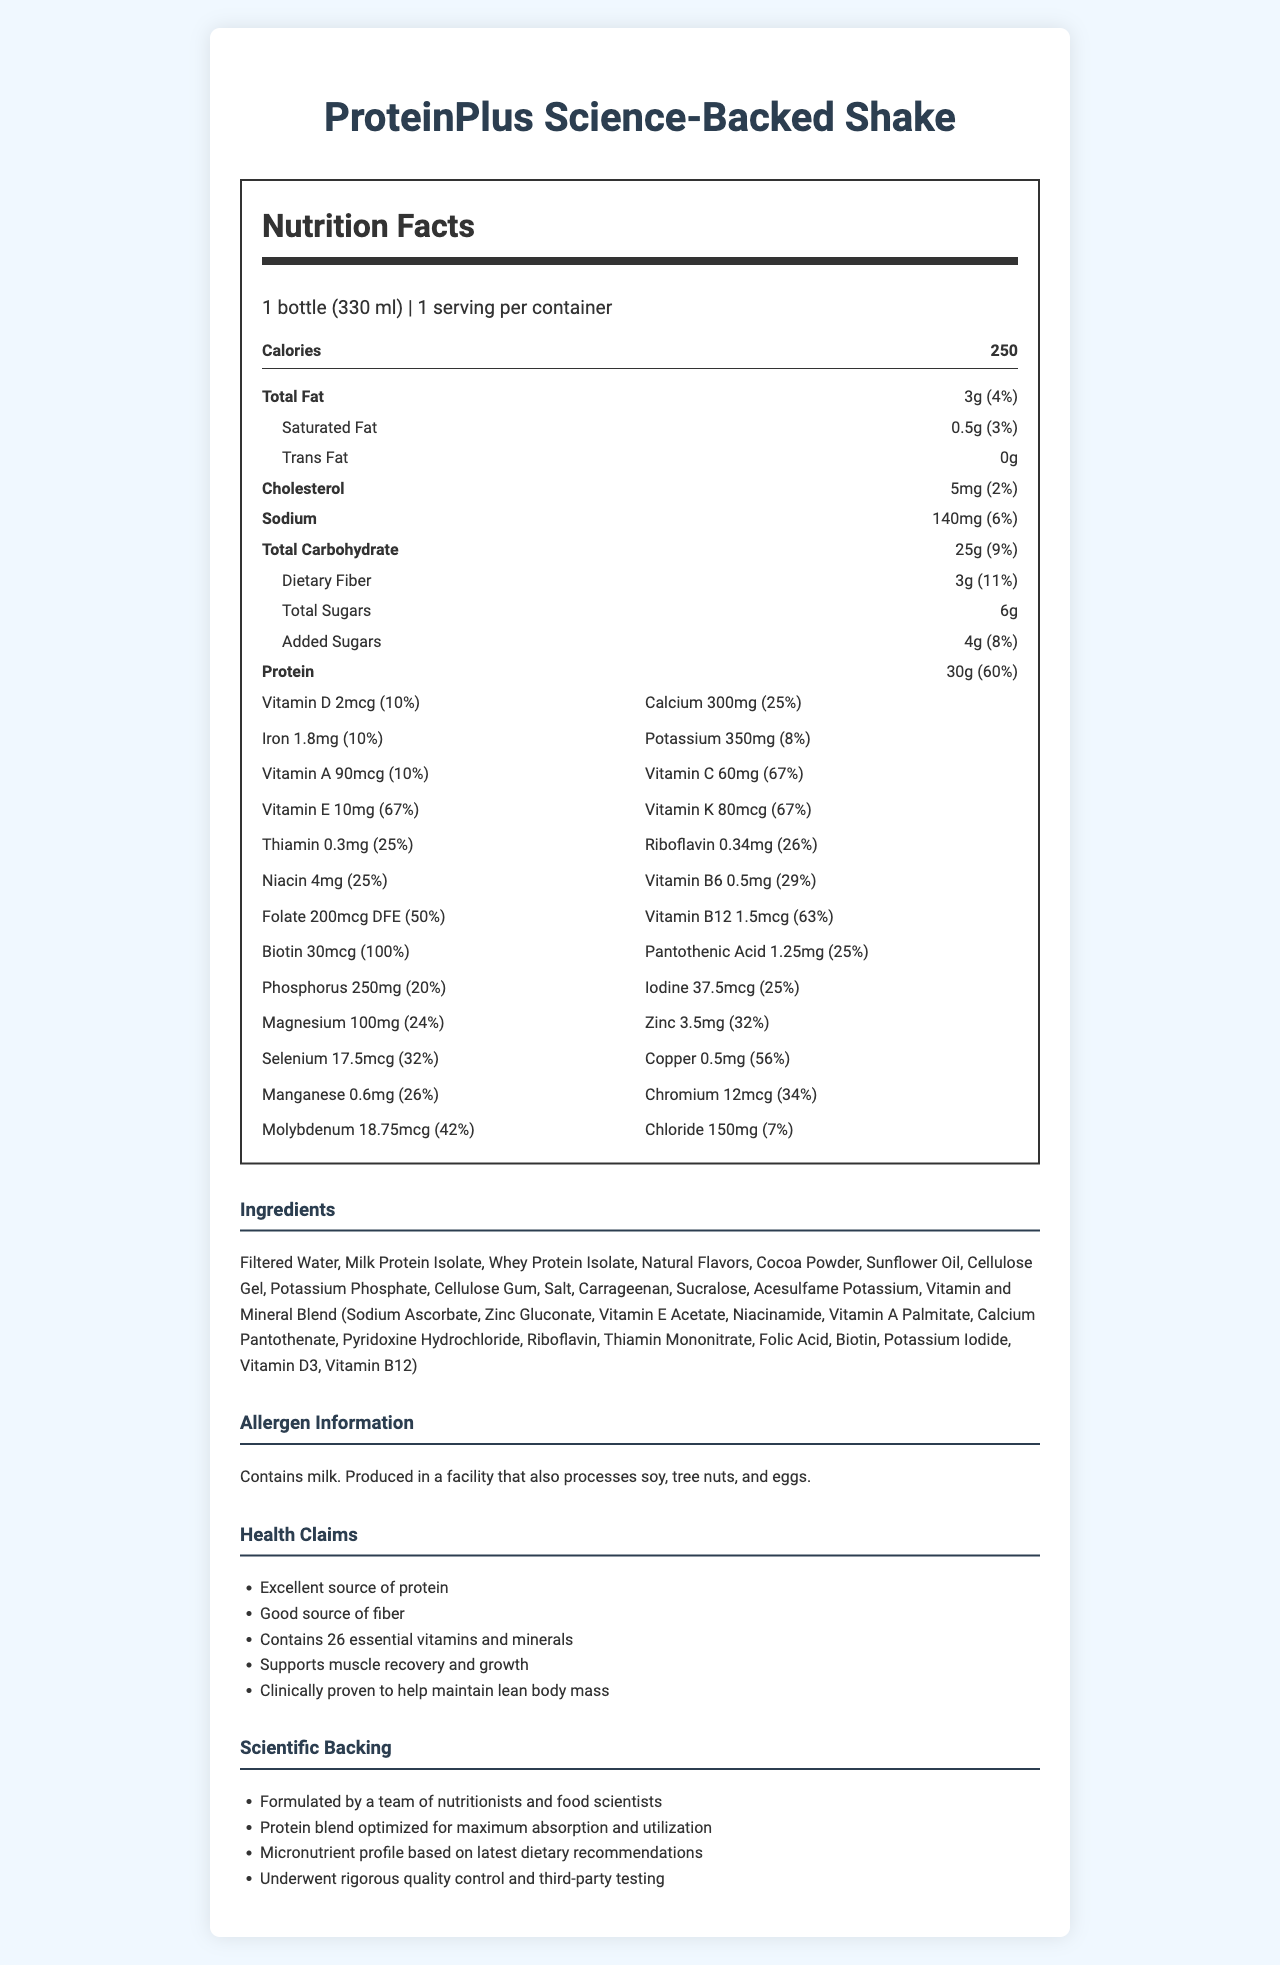what is the serving size of the ProteinPlus Science-Backed Shake? The serving size is listed in the serving information section as "1 bottle (330 ml)".
Answer: 1 bottle (330 ml) how many calories does the shake have per serving? The document states that there are 250 calories per serving, located right under the Nutrition Facts heading.
Answer: 250 calories how much protein does the shake contain? The document lists protein content as 30g under the nutrient breakdown.
Answer: 30g what percentage of the daily value of calcium does the shake provide? The document specifies that the shake contains 300mg of calcium which constitutes 25% of the daily value.
Answer: 25% what is the amount of vitamin B12 in the shake? The vitamin content section lists 1.5mcg of vitamin B12, providing 63% of the daily value.
Answer: 1.5mcg which of the following vitamins has the highest daily value percentage? A. Vitamin A B. Vitamin C C. Vitamin E D. Vitamin B12 The document shows Vitamin E, Vitamin C, and Vitamin K each at 67% of the daily value, tied for the highest percentage.
Answer: C which ingredient is not present in the shake's list? A. Sucralose B. Almond Milk C. Cellulose Gel D. Whey Protein Isolate Almond Milk is not listed in the ingredient section, while the other options are.
Answer: B does the protein shake contain milk? The allergen information section states that the shake contains milk.
Answer: Yes describe the main idea of the document The document presents an in-depth look at the shake's nutritional profile, focusing on what micronutrients are included, their daily value percentages, and additional health benefits backed by scientific research.
Answer: The document provides detailed nutritional information about ProteinPlus Science-Backed Shake, highlighting its macro and micronutrient content, ingredients, allergen information, health claims, and scientific backing. can the nutritional information be applied to understand the shake's effect on muscle recovery and growth? The health claims section states that the shake supports muscle recovery and growth, likely due to its high protein content and other nutrients that aid in these processes.
Answer: Yes how much dietary fiber is in the shake? The document lists the dietary fiber content as 3g, which is 11% of the daily value.
Answer: 3g are any tree nuts listed in the ingredients? While the allergen information notes that the product is produced in a facility that processes tree nuts, no tree nuts are listed in the ingredients.
Answer: No what is the total amount of sugars in the shake? The document states that the shake contains 6g of total sugars and 4g of added sugars.
Answer: 6g how much selenium does the shake provide? The selenium content is listed as 17.5mcg, covering 32% of the daily value.
Answer: 17.5mcg how many essential vitamins and minerals does the shake reportedly contain? According to the health claims section, the shake contains 26 essential vitamins and minerals.
Answer: 26 what is the scientific backing for the protein blend in this shake? The scientific backing section states that the protein blend is optimized for maximum absorption and utilization.
Answer: Protein blend optimized for maximum absorption and utilization what is the phosphorus content in the shake? A. 100mg B. 150mg C. 250mg D. 300mg The phosphorus content is listed as 250mg, which constitutes 20% of the daily value.
Answer: C how many servings are in one container of the shake? The document specifies that there is 1 serving per container.
Answer: 1 